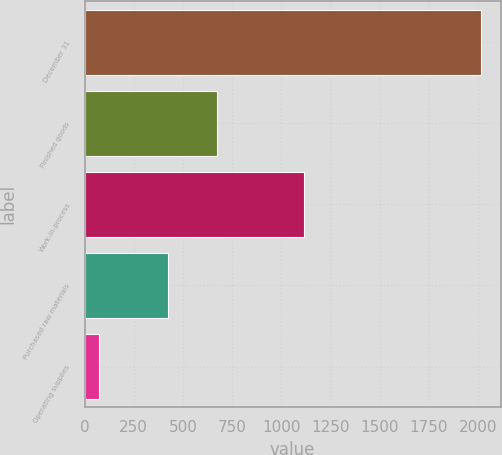Convert chart. <chart><loc_0><loc_0><loc_500><loc_500><bar_chart><fcel>December 31<fcel>Finished goods<fcel>Work-in-process<fcel>Purchased raw materials<fcel>Operating supplies<nl><fcel>2015<fcel>672<fcel>1115<fcel>425<fcel>72<nl></chart> 